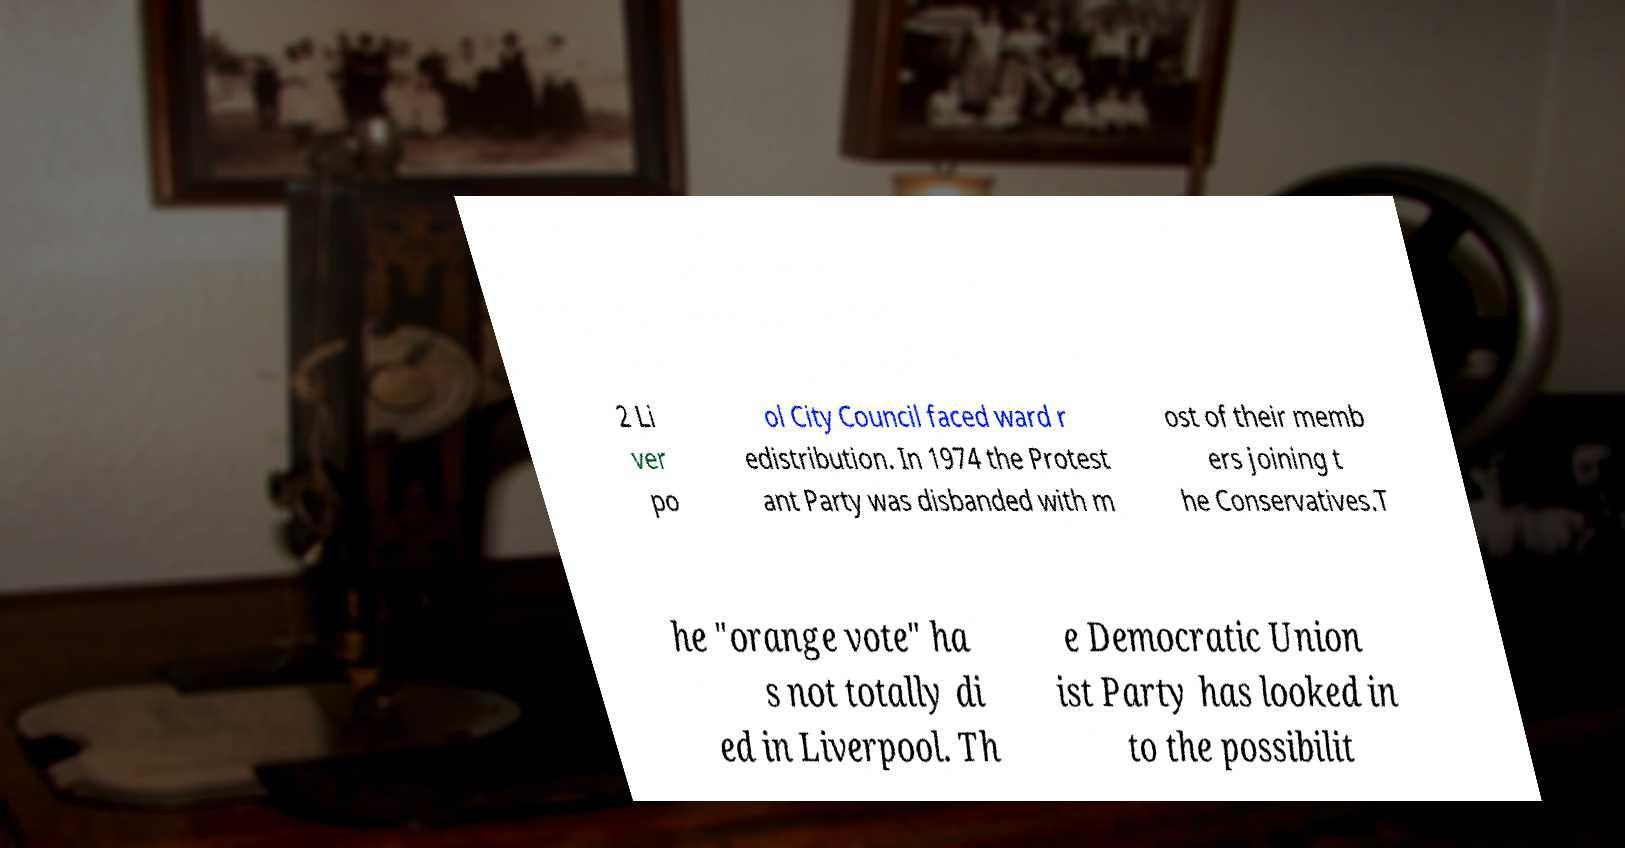There's text embedded in this image that I need extracted. Can you transcribe it verbatim? 2 Li ver po ol City Council faced ward r edistribution. In 1974 the Protest ant Party was disbanded with m ost of their memb ers joining t he Conservatives.T he "orange vote" ha s not totally di ed in Liverpool. Th e Democratic Union ist Party has looked in to the possibilit 